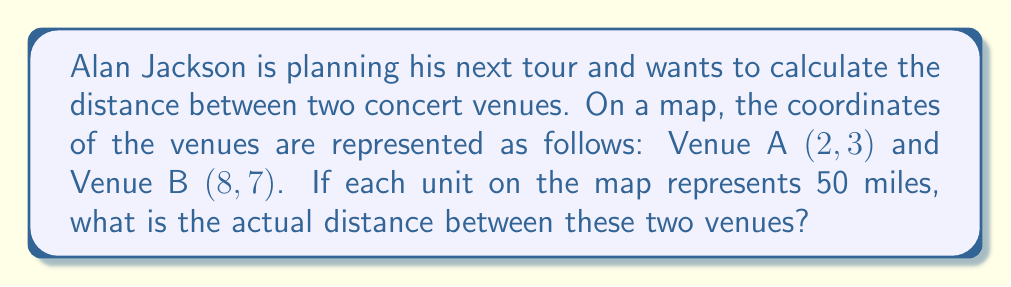Give your solution to this math problem. Let's approach this step-by-step:

1) First, we need to calculate the distance between the two points on the map using the distance formula:

   $$ d = \sqrt{(x_2 - x_1)^2 + (y_2 - y_1)^2} $$

   Where $(x_1, y_1)$ are the coordinates of Venue A and $(x_2, y_2)$ are the coordinates of Venue B.

2) Let's substitute the given coordinates:

   $$ d = \sqrt{(8 - 2)^2 + (7 - 3)^2} $$

3) Simplify inside the parentheses:

   $$ d = \sqrt{6^2 + 4^2} $$

4) Calculate the squares:

   $$ d = \sqrt{36 + 16} $$

5) Add under the square root:

   $$ d = \sqrt{52} $$

6) Simplify the square root:

   $$ d = 2\sqrt{13} $$

7) This gives us the distance in map units. To get the actual distance, we multiply by 50 (since each unit represents 50 miles):

   $$ \text{Actual Distance} = 2\sqrt{13} \times 50 = 100\sqrt{13} \text{ miles} $$

8) If we want to approximate this:

   $$ 100\sqrt{13} \approx 361.25 \text{ miles} $$

[asy]
unitsize(20);
dot((2,3));
dot((8,7));
draw((2,3)--(8,7), arrow=Arrow(TeXHead));
label("Venue A (2,3)", (2,3), SW);
label("Venue B (8,7)", (8,7), NE);
label("$100\sqrt{13}$ miles", (5,5), SE);
[/asy]
Answer: $100\sqrt{13}$ miles 